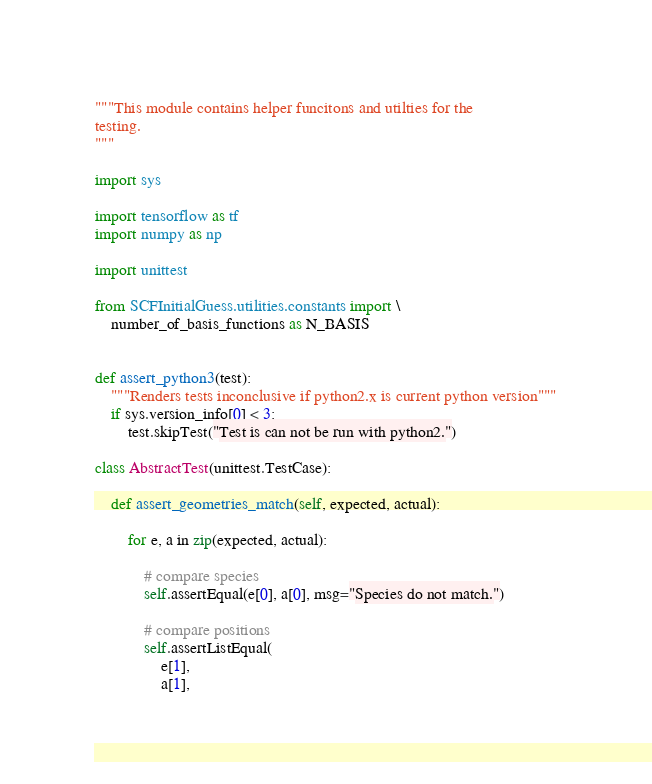<code> <loc_0><loc_0><loc_500><loc_500><_Python_>"""This module contains helper funcitons and utilties for the
testing.
"""

import sys

import tensorflow as tf
import numpy as np

import unittest

from SCFInitialGuess.utilities.constants import \
    number_of_basis_functions as N_BASIS


def assert_python3(test):
    """Renders tests inconclusive if python2.x is current python version"""
    if sys.version_info[0] < 3:
        test.skipTest("Test is can not be run with python2.")

class AbstractTest(unittest.TestCase):

    def assert_geometries_match(self, expected, actual):

        for e, a in zip(expected, actual):

            # compare species
            self.assertEqual(e[0], a[0], msg="Species do not match.")

            # compare positions
            self.assertListEqual(
                e[1], 
                a[1], </code> 